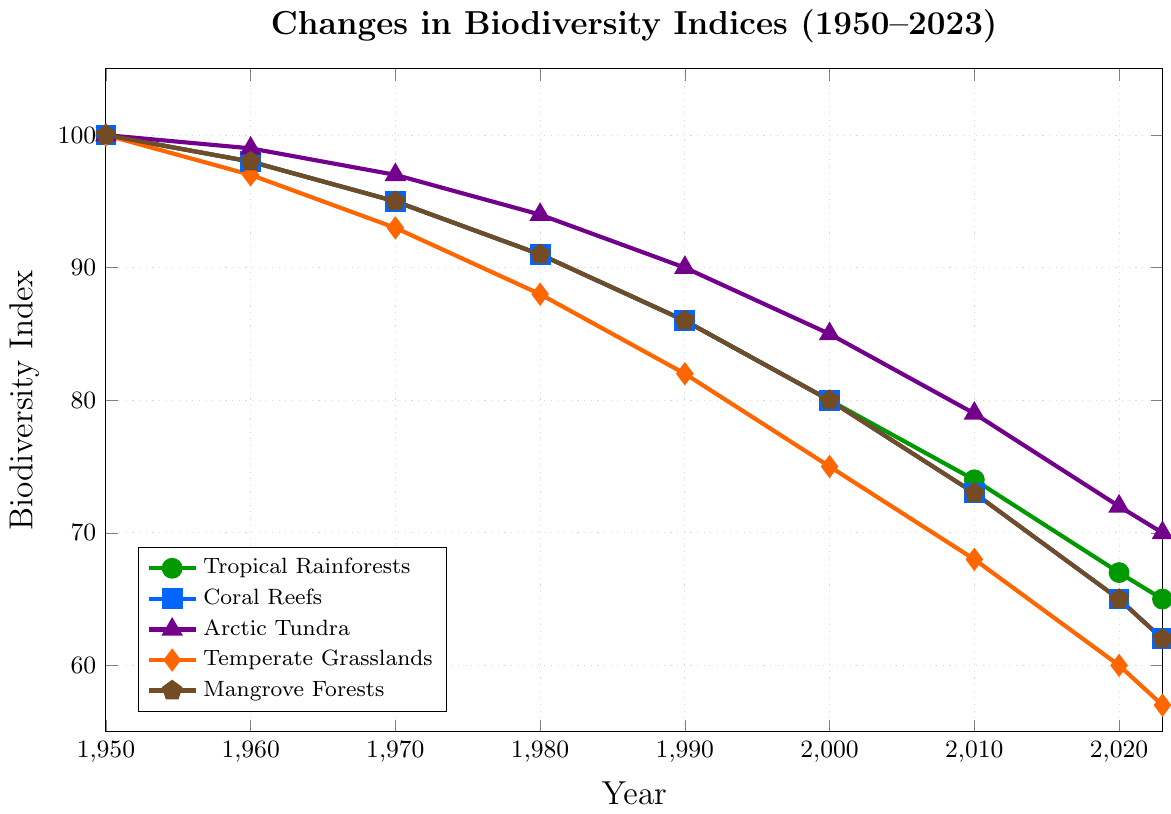What is the overall trend in the biodiversity index for Tropical Rainforests from 1950 to 2023? The graph clearly shows a declining trend in the biodiversity index for Tropical Rainforests from 1950 (100) to 2023 (65).
Answer: Declining Between which years did the Coral Reefs show the steepest decline in biodiversity index? The steepest decline can be determined by observing the largest decrease in value over consecutive years. From 2010 (73) to 2020 (65) and then to 2023 (62), there is a significant drop. The specific steepest decline occurs between 2010 to 2020.
Answer: 2010 to 2020 By how much did the biodiversity index for Temperate Grasslands change between 1950 and 2023? The biodiversity index for Temperate Grasslands was 100 in 1950 and 57 in 2023. The change is calculated as 100 - 57 = 43.
Answer: 43 Which ecosystem had the highest biodiversity index in 2023? To answer this, compare the indices for all ecosystems in 2023: Tropical Rainforests (65), Coral Reefs (62), Arctic Tundra (70), Temperate Grasslands (57), and Mangrove Forests (62). Arctic Tundra has the highest value at 70.
Answer: Arctic Tundra How did the biodiversity index of Mangrove Forests compare to Coral Reefs in 1970? In 1970, both the Mangrove Forests and Coral Reefs had a biodiversity index of 95, indicating they were equal.
Answer: Equal What is the average decline rate per decade for Arctic Tundra from 1950 to 2023? The Arctic Tundra's biodiversity index declined from 100 in 1950 to 70 in 2023 over approximately 7.3 decades (2023-1950). The total decline is 100 - 70 = 30. The average decline rate per decade is 30 / 7.3 = ~4.11.
Answer: ~4.11 Which ecosystem experienced the lowest biodiversity index in 2000? For the year 2000, compare all the ecosystems' indices: Tropical Rainforests (80), Coral Reefs (80), Arctic Tundra (85), Temperate Grasslands (75), Mangrove Forests (80). The lowest index is for Temperate Grasslands at 75.
Answer: Temperate Grasslands What is the difference in the biodiversity index of Mangrove Forests between 1960 and 2020? The indices for Mangrove Forests are 98 in 1960 and 65 in 2020. The difference is calculated as 98 - 65 = 33.
Answer: 33 How many ecosystems had a biodiversity index below 70 in 2023? The indices for 2023 are Tropical Rainforests (65), Coral Reefs (62), Arctic Tundra (70), Temperate Grasslands (57), and Mangrove Forests (62). Four ecosystems have an index below 70: Tropical Rainforests, Coral Reefs, Temperate Grasslands, and Mangrove Forests.
Answer: 4 